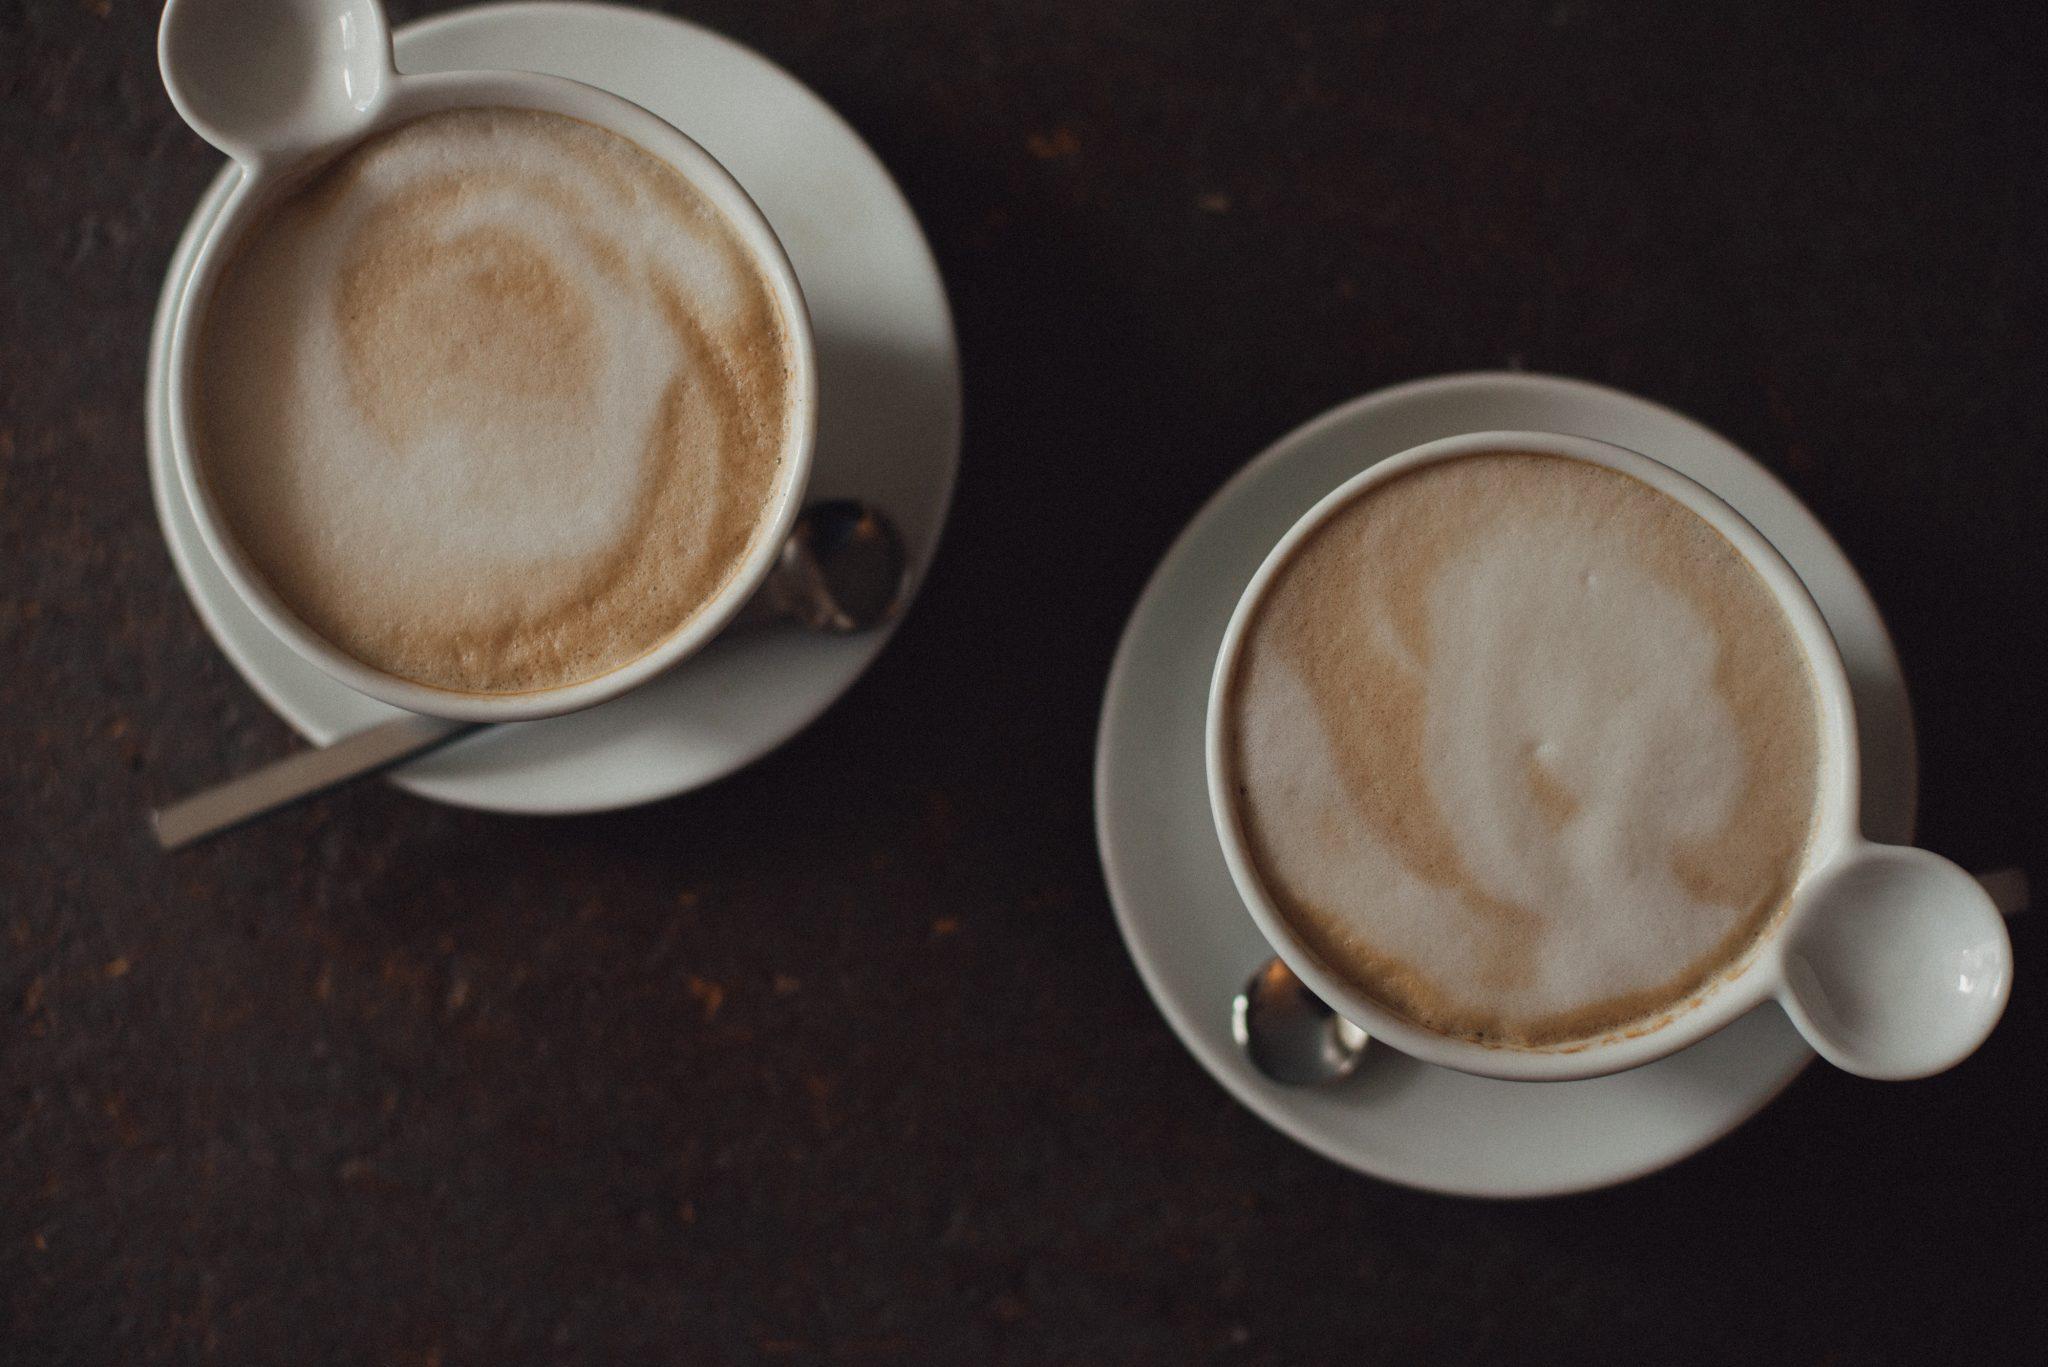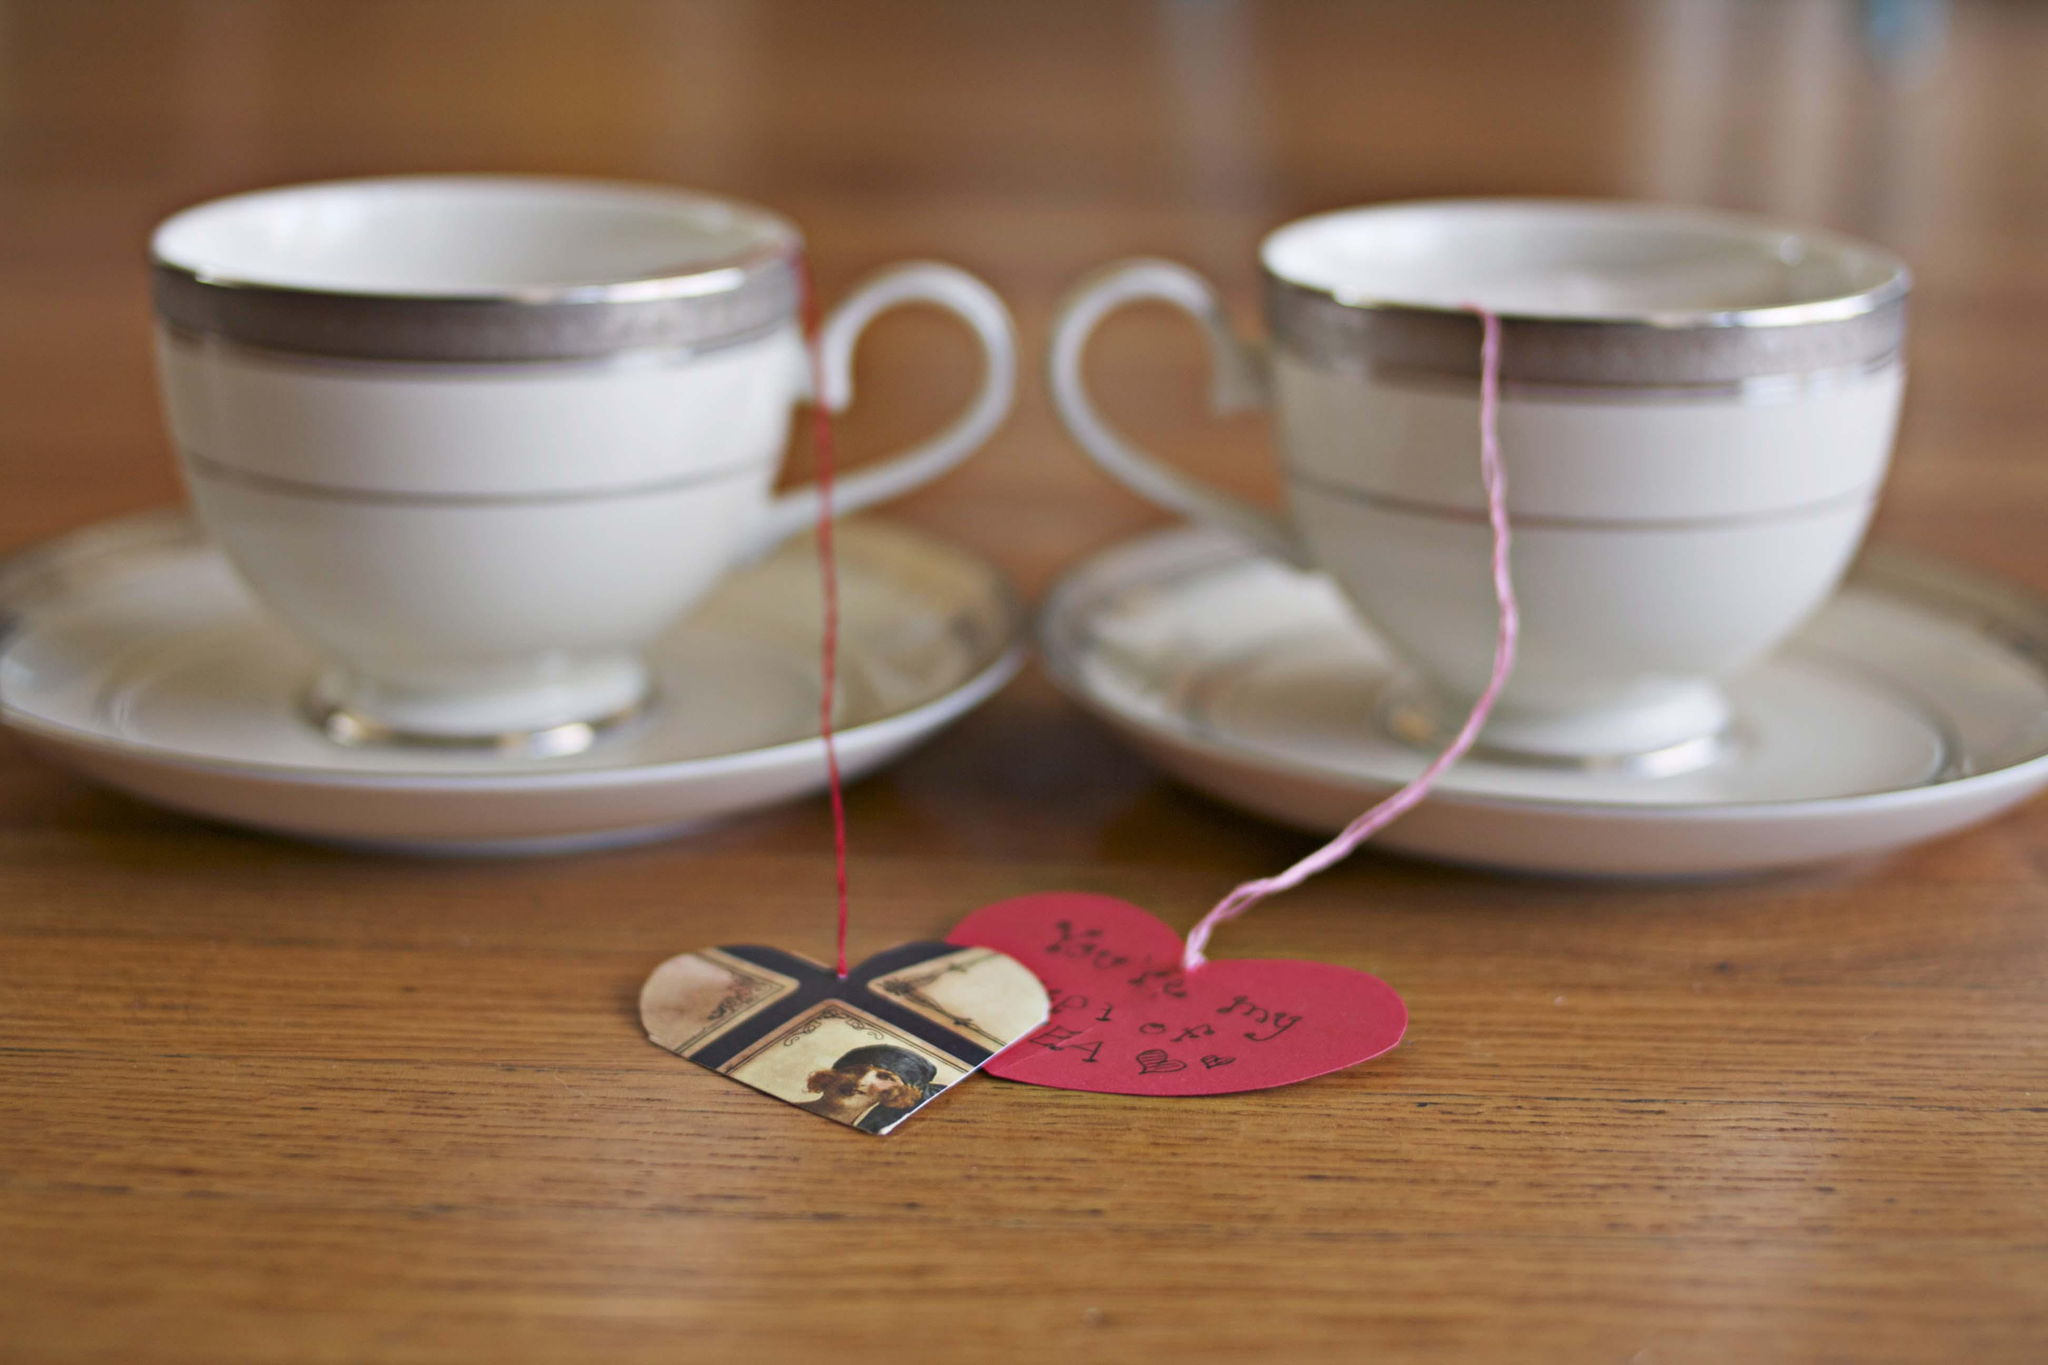The first image is the image on the left, the second image is the image on the right. Examine the images to the left and right. Is the description "One image appears to depict two completely empty cups." accurate? Answer yes or no. No. The first image is the image on the left, the second image is the image on the right. Assess this claim about the two images: "Two cups for hot drinks are in each image, each sitting on a matching saucer.". Correct or not? Answer yes or no. Yes. The first image is the image on the left, the second image is the image on the right. For the images displayed, is the sentence "Left image shows two cups of the same beverages on white saucers." factually correct? Answer yes or no. Yes. The first image is the image on the left, the second image is the image on the right. Considering the images on both sides, is "There are four tea cups sitting  on saucers." valid? Answer yes or no. Yes. 